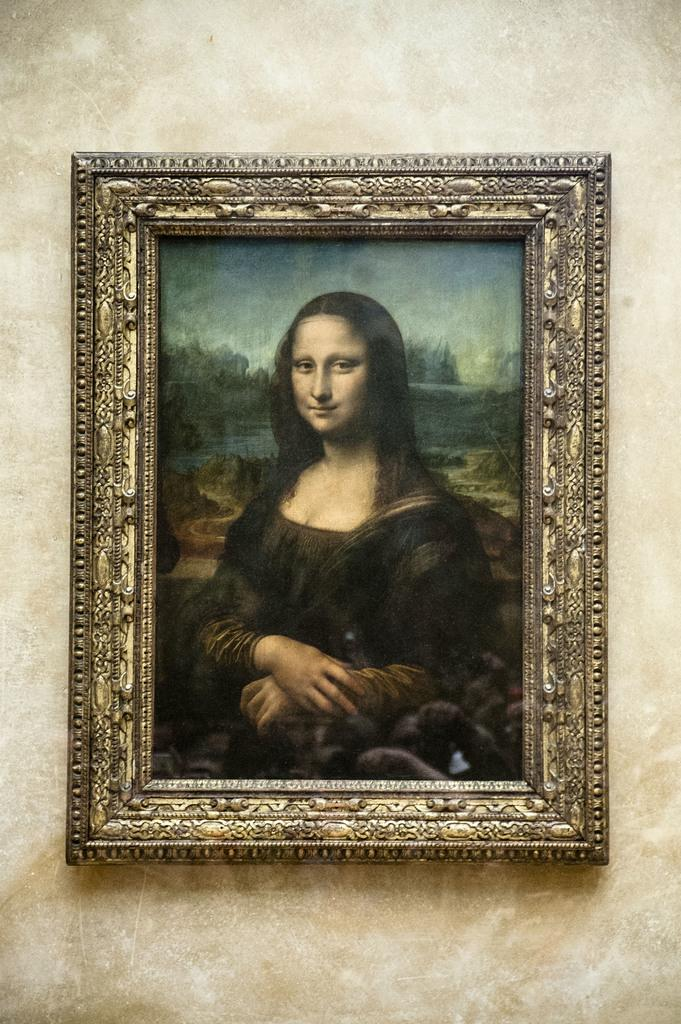What is hanging on the wall in the image? There is a frame on the wall in the image. What is depicted within the frame? Mona Lisa is present in the frame. What type of grass can be seen growing around the frame in the image? There is no grass present in the image; it features a frame with the Mona Lisa on a wall. 